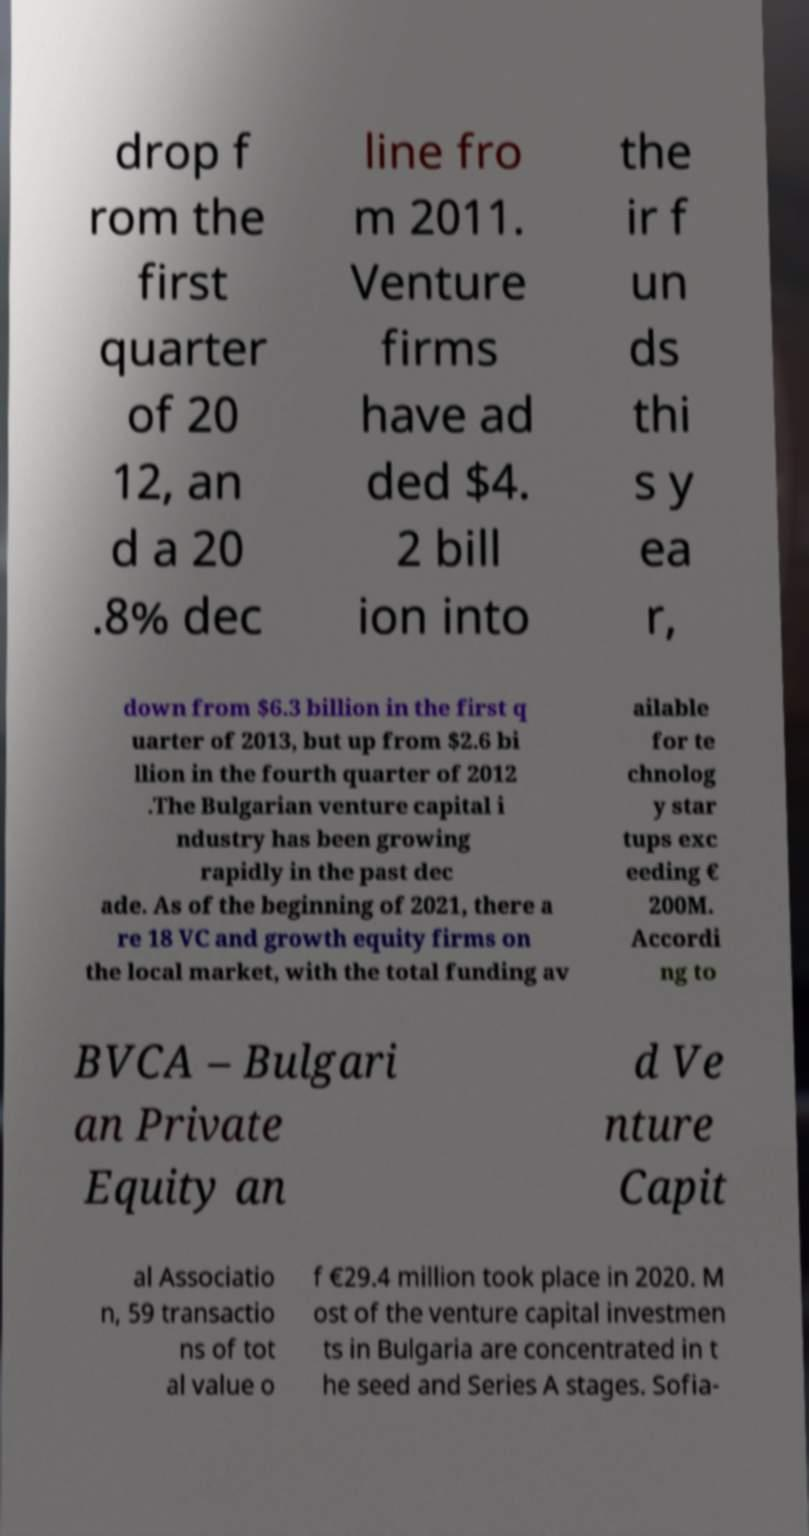What messages or text are displayed in this image? I need them in a readable, typed format. drop f rom the first quarter of 20 12, an d a 20 .8% dec line fro m 2011. Venture firms have ad ded $4. 2 bill ion into the ir f un ds thi s y ea r, down from $6.3 billion in the first q uarter of 2013, but up from $2.6 bi llion in the fourth quarter of 2012 .The Bulgarian venture capital i ndustry has been growing rapidly in the past dec ade. As of the beginning of 2021, there a re 18 VC and growth equity firms on the local market, with the total funding av ailable for te chnolog y star tups exc eeding € 200M. Accordi ng to BVCA – Bulgari an Private Equity an d Ve nture Capit al Associatio n, 59 transactio ns of tot al value o f €29.4 million took place in 2020. M ost of the venture capital investmen ts in Bulgaria are concentrated in t he seed and Series A stages. Sofia- 